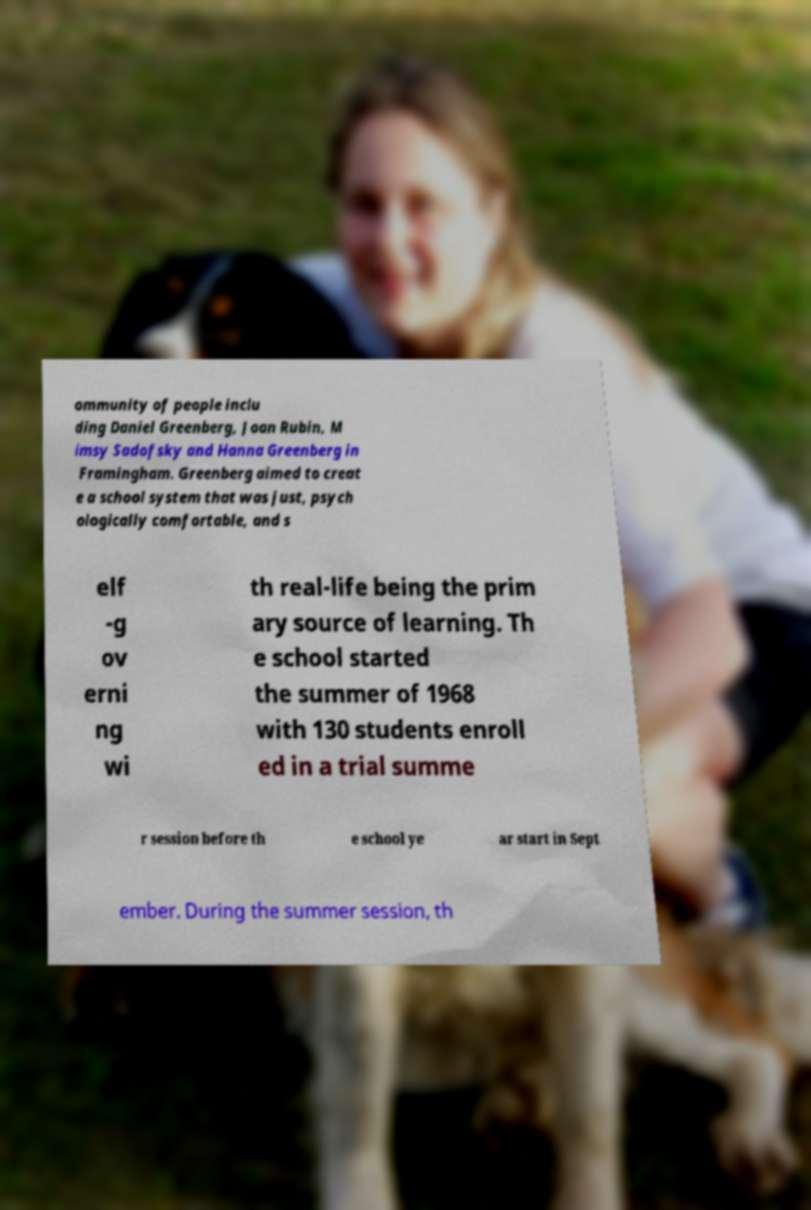There's text embedded in this image that I need extracted. Can you transcribe it verbatim? ommunity of people inclu ding Daniel Greenberg, Joan Rubin, M imsy Sadofsky and Hanna Greenberg in Framingham. Greenberg aimed to creat e a school system that was just, psych ologically comfortable, and s elf -g ov erni ng wi th real-life being the prim ary source of learning. Th e school started the summer of 1968 with 130 students enroll ed in a trial summe r session before th e school ye ar start in Sept ember. During the summer session, th 